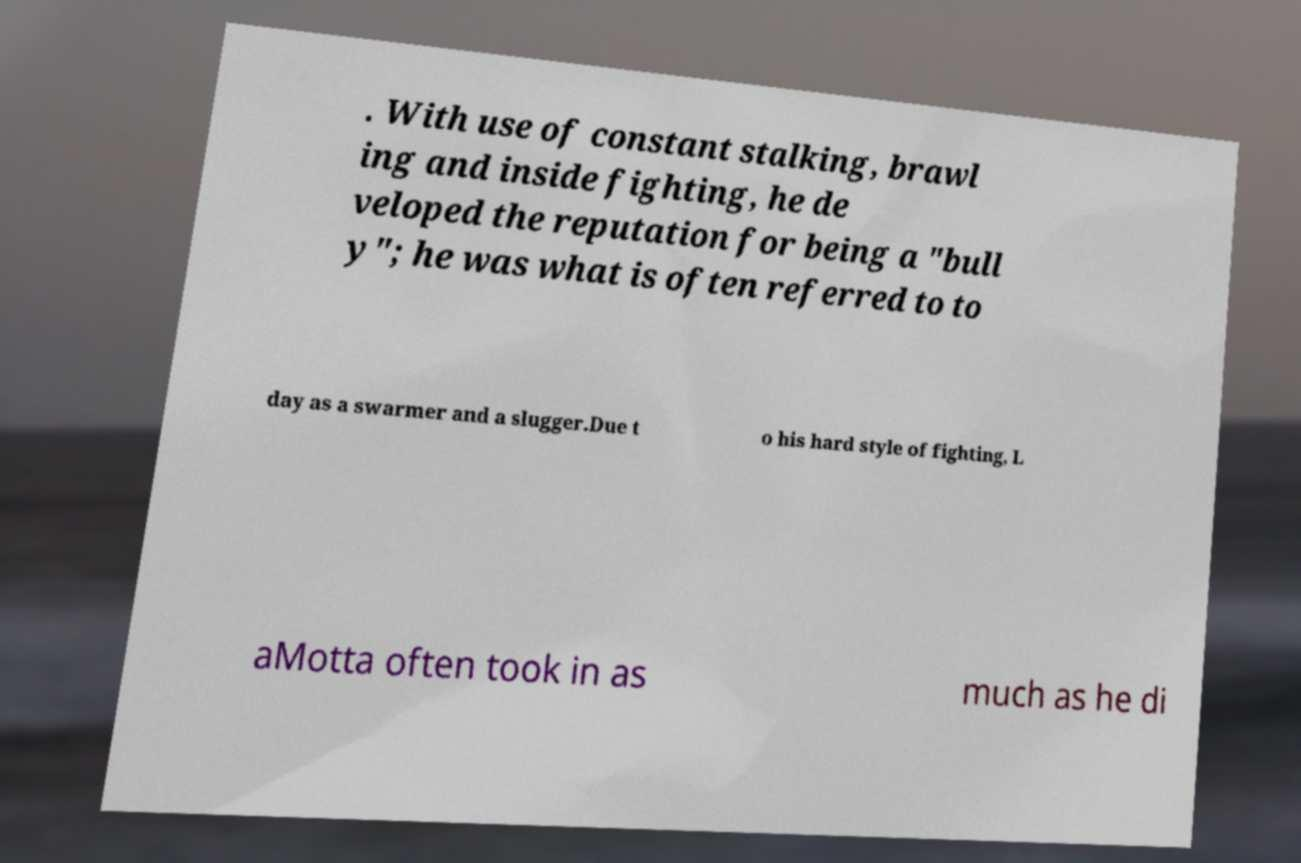Could you extract and type out the text from this image? . With use of constant stalking, brawl ing and inside fighting, he de veloped the reputation for being a "bull y"; he was what is often referred to to day as a swarmer and a slugger.Due t o his hard style of fighting, L aMotta often took in as much as he di 